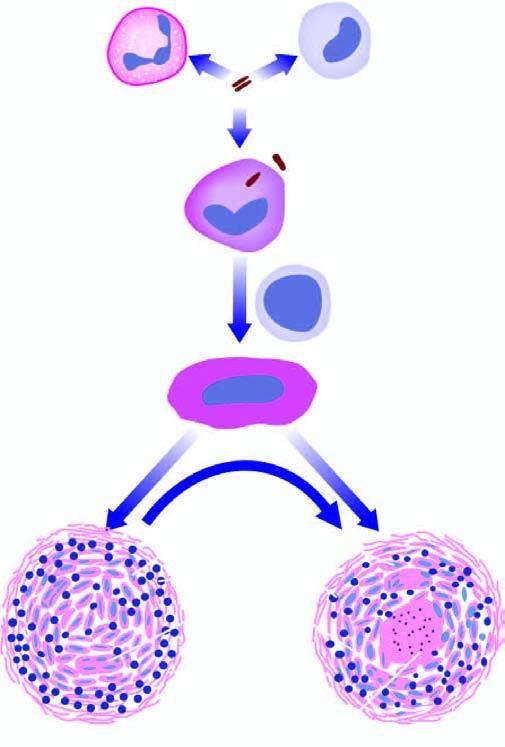s the centre composed of granular caseation necrosis, surrounded by epithelioid cells and langhans ' giant cells and peripheral rim of lymphocytes bounded by fibroblasts in fully formed granuloma?
Answer the question using a single word or phrase. Yes 